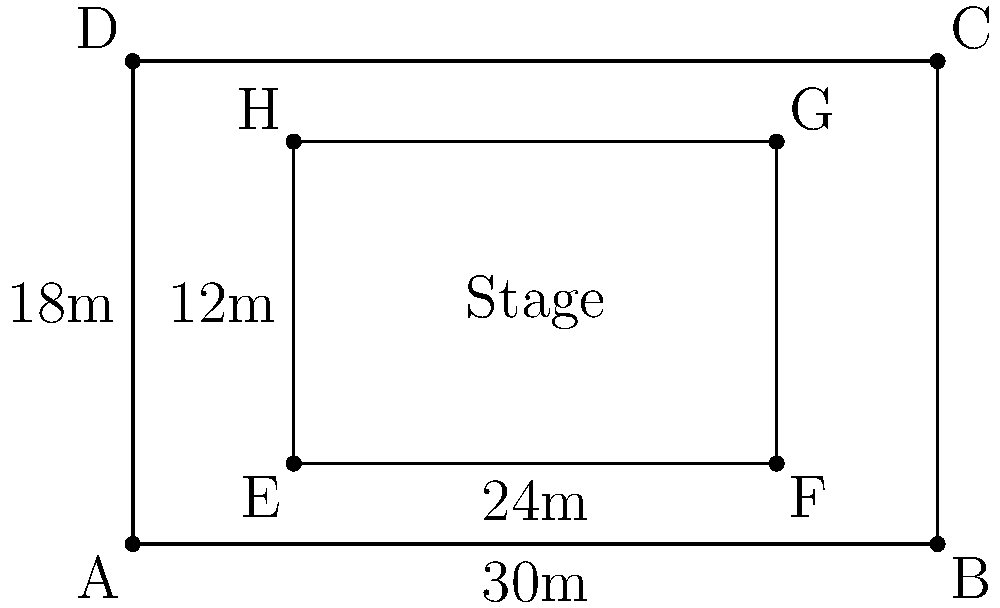As the lead guitarist, you're tasked with optimizing the stage layout for your upcoming punk rock concert. The venue is rectangular, measuring 30m wide and 18m deep. You want to set up a rectangular stage that leaves a 2m gap on all sides for equipment and movement. What is the maximum area (in square meters) that your stage can occupy? Let's approach this step-by-step:

1) The venue dimensions are 30m wide and 18m deep.

2) We need to leave a 2m gap on all sides. This means:
   - Width reduction: 2m on the left + 2m on the right = 4m total
   - Depth reduction: 2m at the front + 2m at the back = 4m total

3) The available space for the stage is:
   - Width: $30m - 4m = 26m$
   - Depth: $18m - 4m = 14m$

4) The area of a rectangle is given by the formula: $A = l * w$, where $A$ is area, $l$ is length (or depth in this case), and $w$ is width.

5) Therefore, the maximum stage area is:
   $A = 26m * 14m = 364m^2$

Thus, the maximum area that your stage can occupy is 364 square meters.
Answer: $364m^2$ 